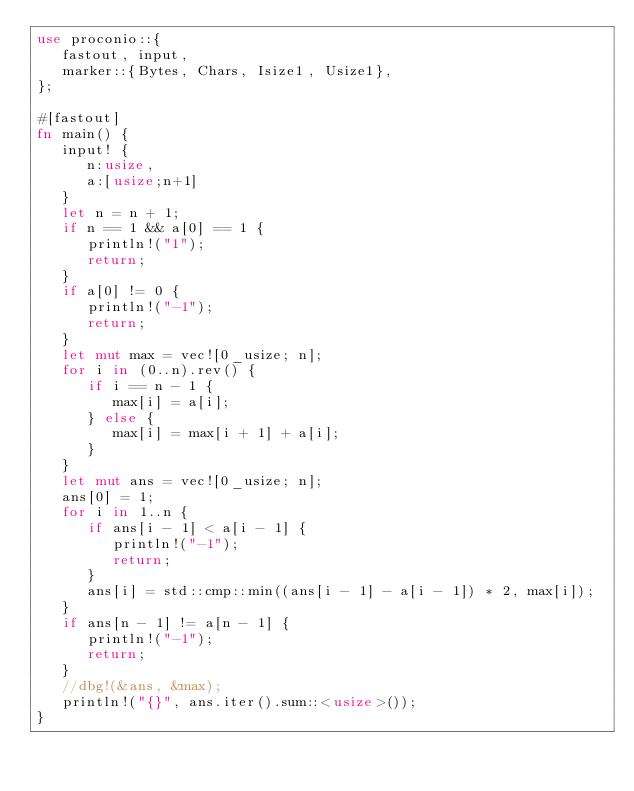Convert code to text. <code><loc_0><loc_0><loc_500><loc_500><_Rust_>use proconio::{
   fastout, input,
   marker::{Bytes, Chars, Isize1, Usize1},
};

#[fastout]
fn main() {
   input! {
      n:usize,
      a:[usize;n+1]
   }
   let n = n + 1;
   if n == 1 && a[0] == 1 {
      println!("1");
      return;
   }
   if a[0] != 0 {
      println!("-1");
      return;
   }
   let mut max = vec![0_usize; n];
   for i in (0..n).rev() {
      if i == n - 1 {
         max[i] = a[i];
      } else {
         max[i] = max[i + 1] + a[i];
      }
   }
   let mut ans = vec![0_usize; n];
   ans[0] = 1;
   for i in 1..n {
      if ans[i - 1] < a[i - 1] {
         println!("-1");
         return;
      }
      ans[i] = std::cmp::min((ans[i - 1] - a[i - 1]) * 2, max[i]);
   }
   if ans[n - 1] != a[n - 1] {
      println!("-1");
      return;
   }
   //dbg!(&ans, &max);
   println!("{}", ans.iter().sum::<usize>());
}
</code> 